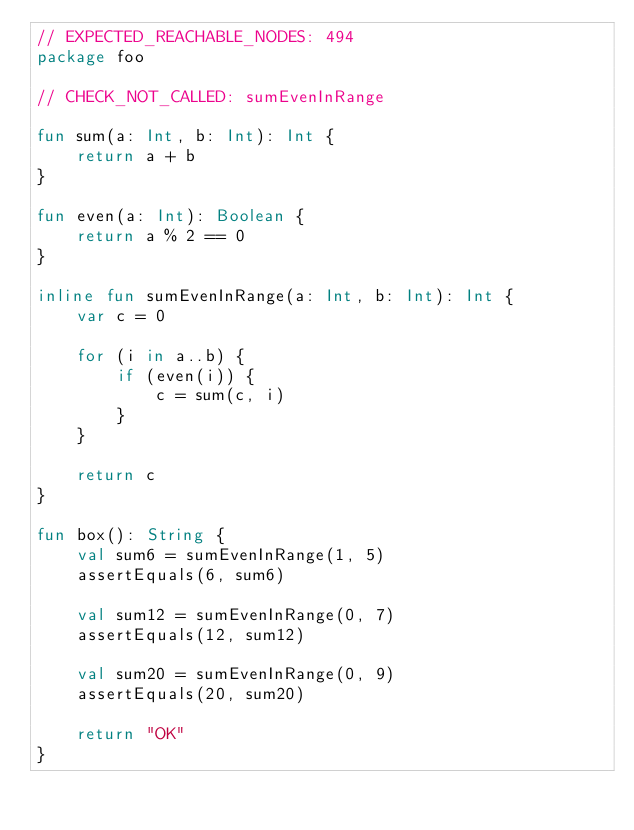Convert code to text. <code><loc_0><loc_0><loc_500><loc_500><_Kotlin_>// EXPECTED_REACHABLE_NODES: 494
package foo

// CHECK_NOT_CALLED: sumEvenInRange

fun sum(a: Int, b: Int): Int {
    return a + b
}

fun even(a: Int): Boolean {
    return a % 2 == 0
}

inline fun sumEvenInRange(a: Int, b: Int): Int {
    var c = 0

    for (i in a..b) {
        if (even(i)) {
            c = sum(c, i)
        }
    }

    return c
}

fun box(): String {
    val sum6 = sumEvenInRange(1, 5)
    assertEquals(6, sum6)

    val sum12 = sumEvenInRange(0, 7)
    assertEquals(12, sum12)

    val sum20 = sumEvenInRange(0, 9)
    assertEquals(20, sum20)

    return "OK"
}</code> 